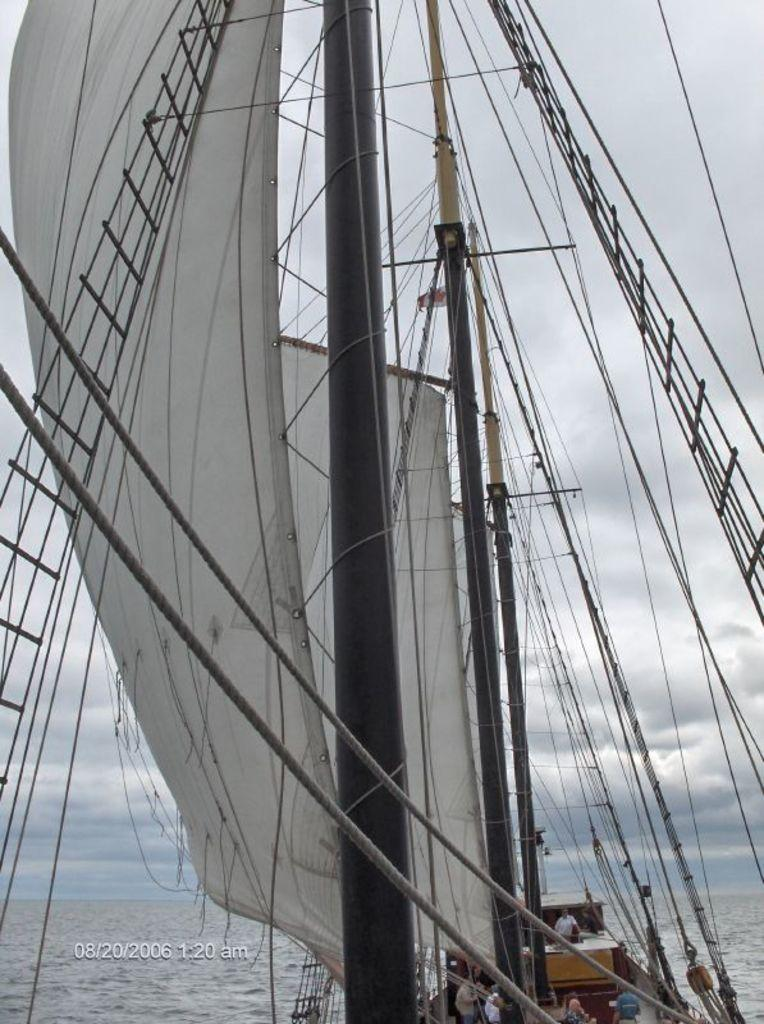What is the main subject of the image? There is a ship in the image. What color is the cloth visible in the image? The cloth in the image is white. What is the setting of the image? There is water visible in the image. What is the weather like in the image? The sky is cloudy in the image. Can you see any houses in the image? There are no houses visible in the image; it features a ship on water. Is there a fork being used to stir steam in the image? There is no fork or steam present in the image. 